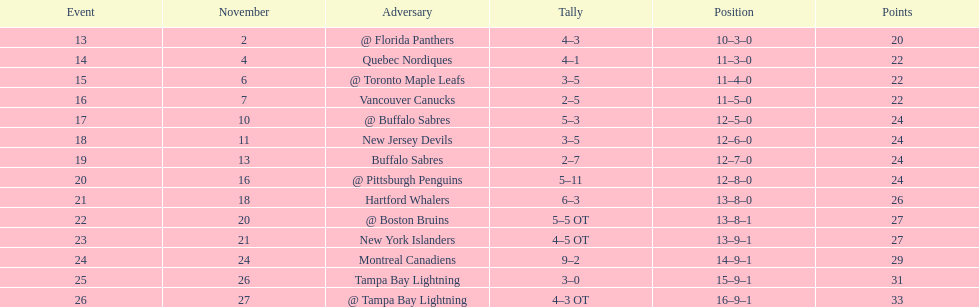Did the tampa bay lightning have the least amount of wins? Yes. 